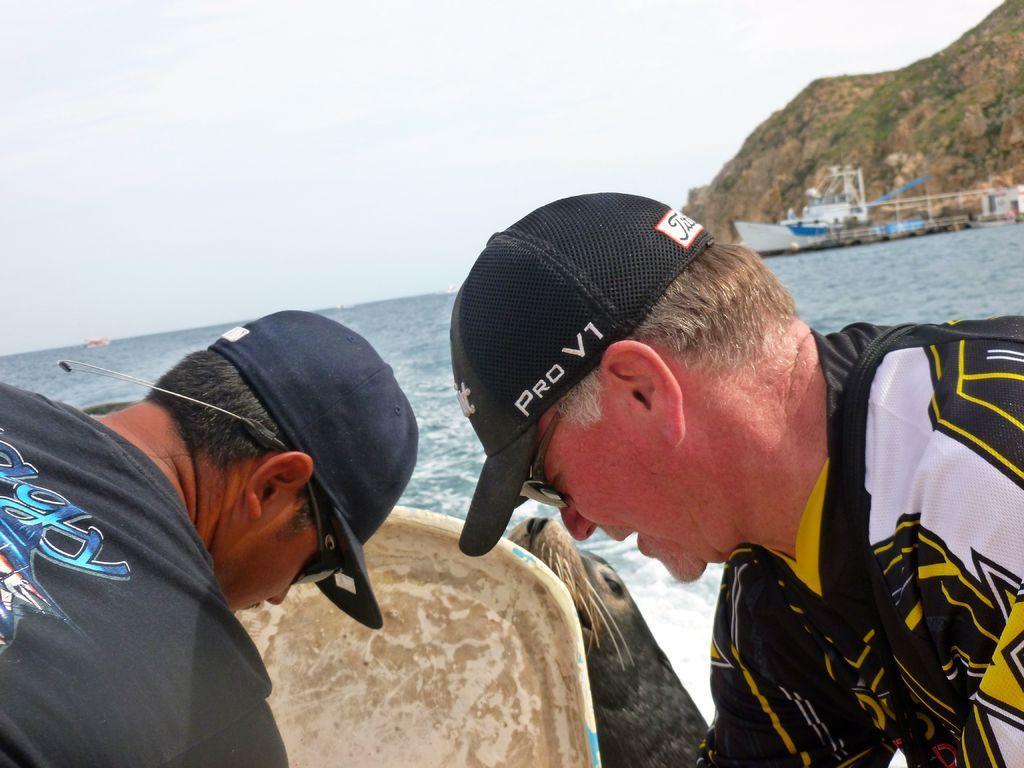Describe this image in one or two sentences. In this picture we can see two men wore caps, goggles, animal, boats on water, mountains and in the background we can see the sky. 